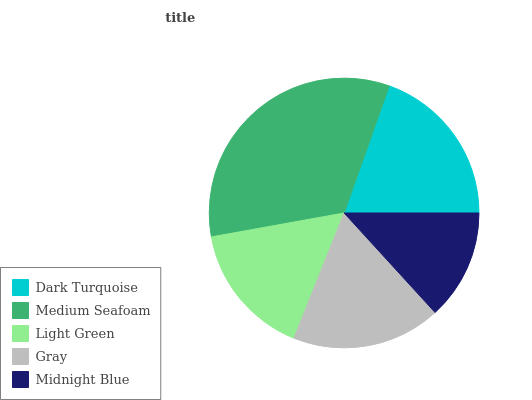Is Midnight Blue the minimum?
Answer yes or no. Yes. Is Medium Seafoam the maximum?
Answer yes or no. Yes. Is Light Green the minimum?
Answer yes or no. No. Is Light Green the maximum?
Answer yes or no. No. Is Medium Seafoam greater than Light Green?
Answer yes or no. Yes. Is Light Green less than Medium Seafoam?
Answer yes or no. Yes. Is Light Green greater than Medium Seafoam?
Answer yes or no. No. Is Medium Seafoam less than Light Green?
Answer yes or no. No. Is Gray the high median?
Answer yes or no. Yes. Is Gray the low median?
Answer yes or no. Yes. Is Dark Turquoise the high median?
Answer yes or no. No. Is Midnight Blue the low median?
Answer yes or no. No. 